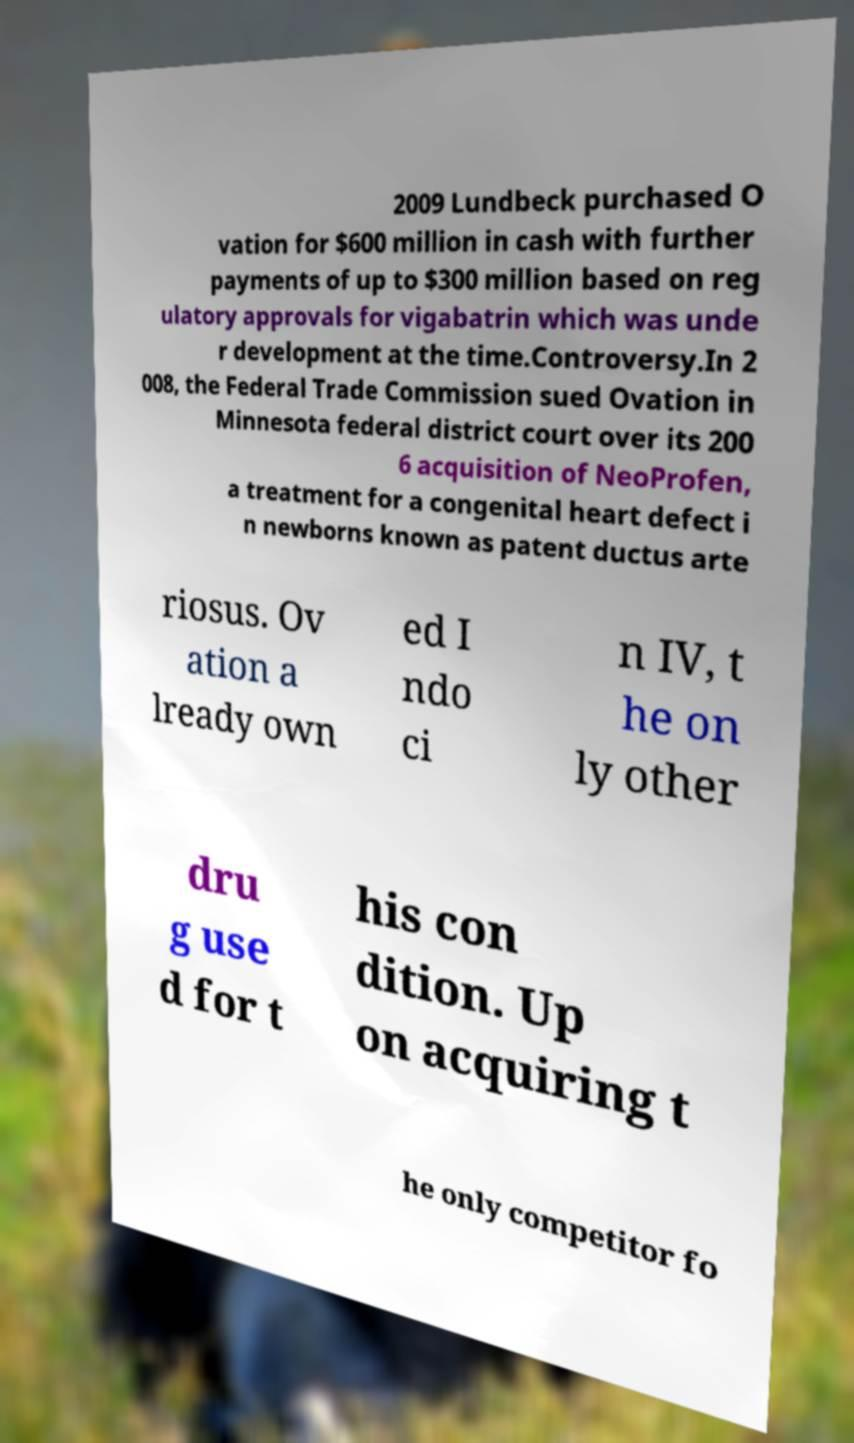I need the written content from this picture converted into text. Can you do that? 2009 Lundbeck purchased O vation for $600 million in cash with further payments of up to $300 million based on reg ulatory approvals for vigabatrin which was unde r development at the time.Controversy.In 2 008, the Federal Trade Commission sued Ovation in Minnesota federal district court over its 200 6 acquisition of NeoProfen, a treatment for a congenital heart defect i n newborns known as patent ductus arte riosus. Ov ation a lready own ed I ndo ci n IV, t he on ly other dru g use d for t his con dition. Up on acquiring t he only competitor fo 